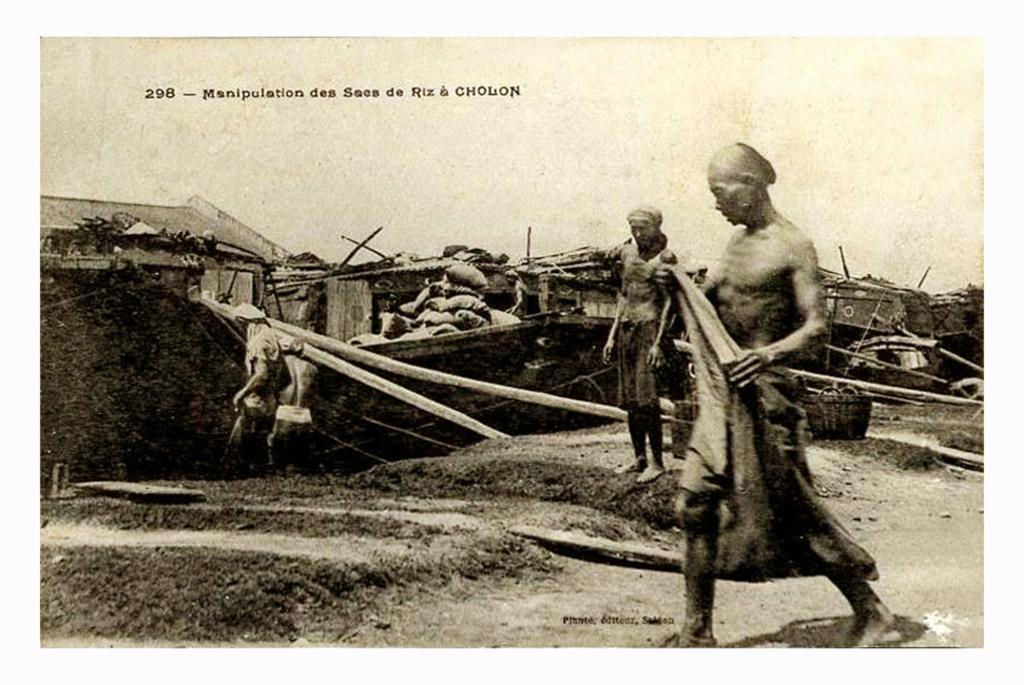How many people are present in the image? There are two people in the image, one standing and one walking. What type of structure is visible in the image? There is a house in the image. What is the ground condition in the image? There is mud in the image. What type of boat can be seen sailing in the mud in the image? There is no boat present in the image; it features a person standing and another walking, a house, and muddy ground. What kind of plants are growing in the store in the image? There is no store or plants mentioned in the image; it only includes a person standing, a person walking, a house, and muddy ground. 